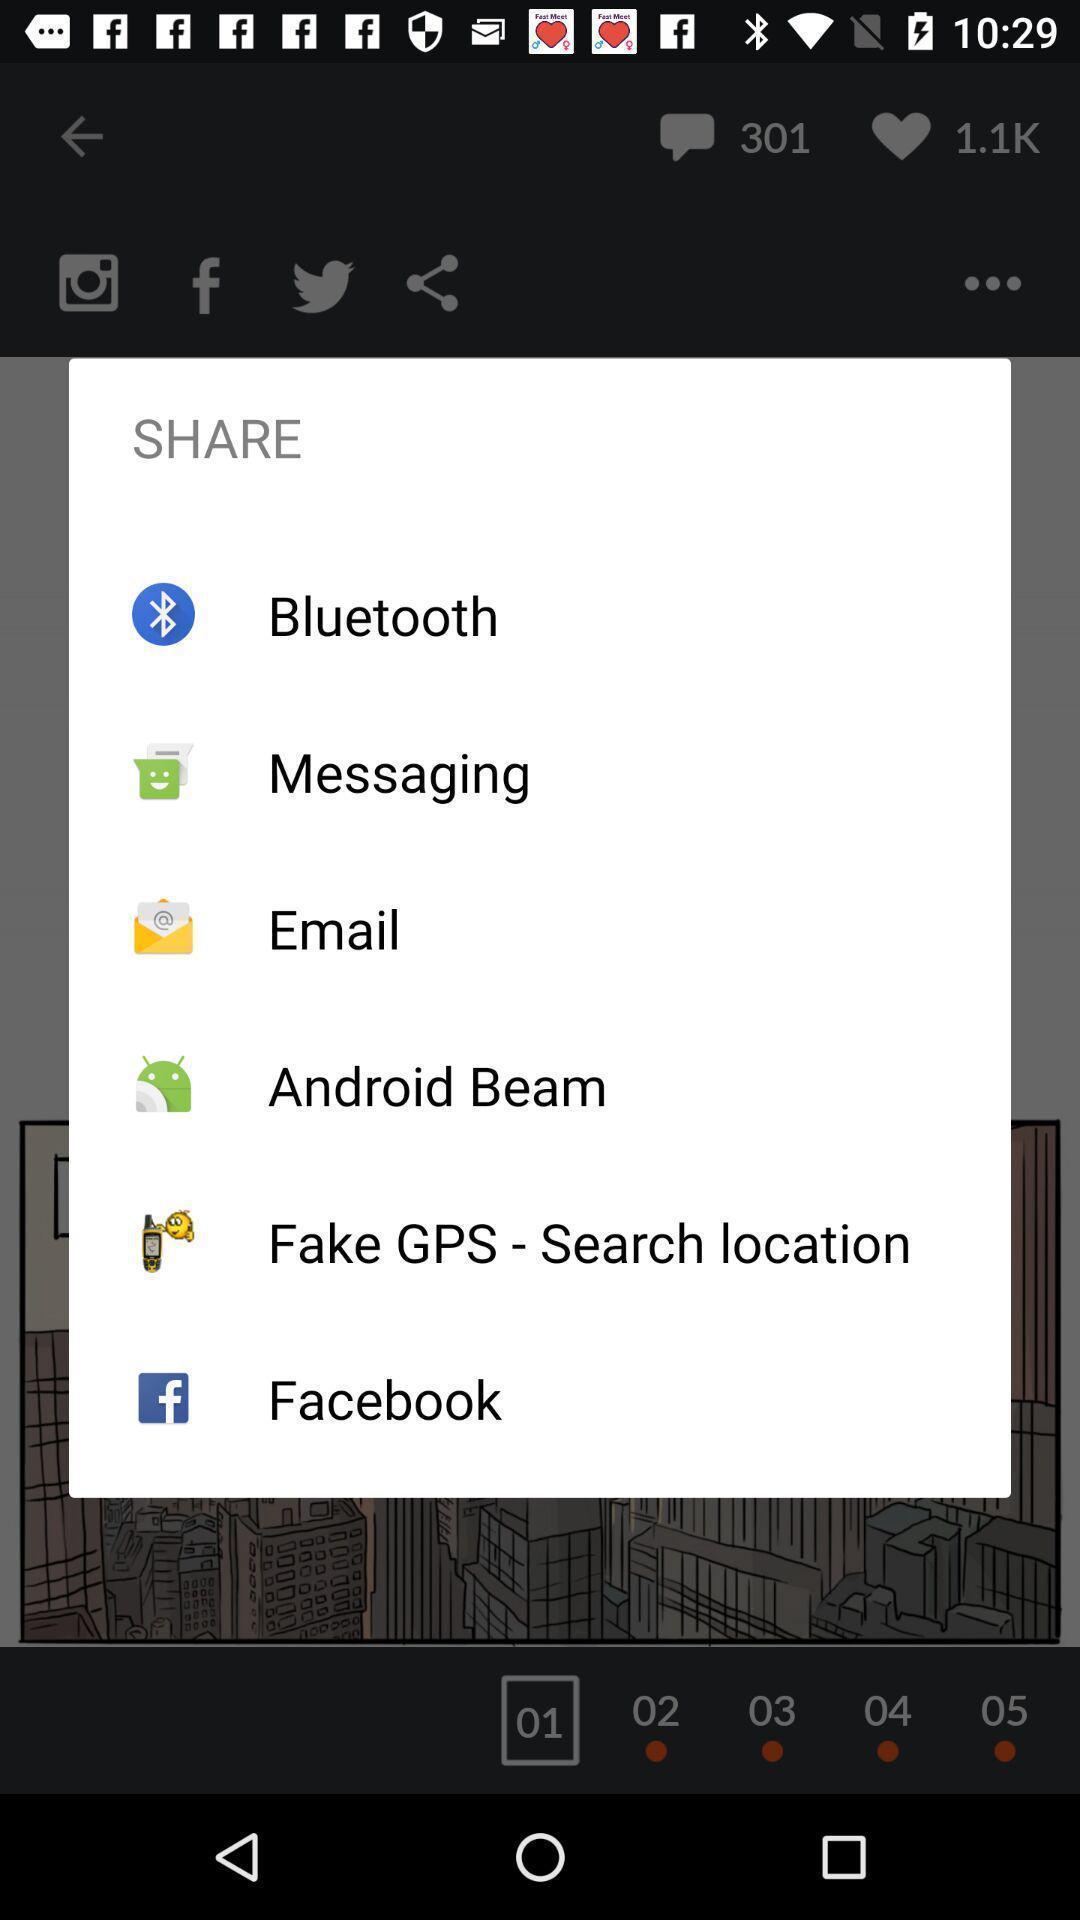What can you discern from this picture? Pop-up shows share option with multiple applications. 